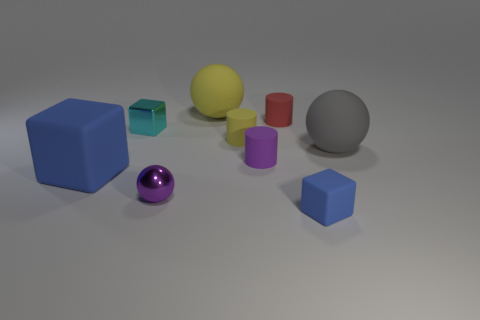There is a tiny purple object behind the blue object behind the small blue rubber cube; how many purple spheres are to the left of it?
Keep it short and to the point. 1. Do the gray matte thing behind the large blue object and the purple metallic thing have the same shape?
Your answer should be compact. Yes. What is the material of the blue block that is on the right side of the cyan block?
Ensure brevity in your answer.  Rubber. There is a thing that is both on the right side of the purple matte cylinder and behind the large gray rubber ball; what is its shape?
Give a very brief answer. Cylinder. What is the tiny blue cube made of?
Provide a short and direct response. Rubber. What number of spheres are big gray objects or small cyan things?
Offer a terse response. 1. Are the small purple sphere and the big blue cube made of the same material?
Provide a short and direct response. No. The other metallic thing that is the same shape as the large yellow thing is what size?
Offer a terse response. Small. There is a object that is behind the purple sphere and to the right of the tiny red cylinder; what is its material?
Provide a succinct answer. Rubber. Are there an equal number of small cyan metallic blocks in front of the small cyan object and shiny balls?
Make the answer very short. No. 